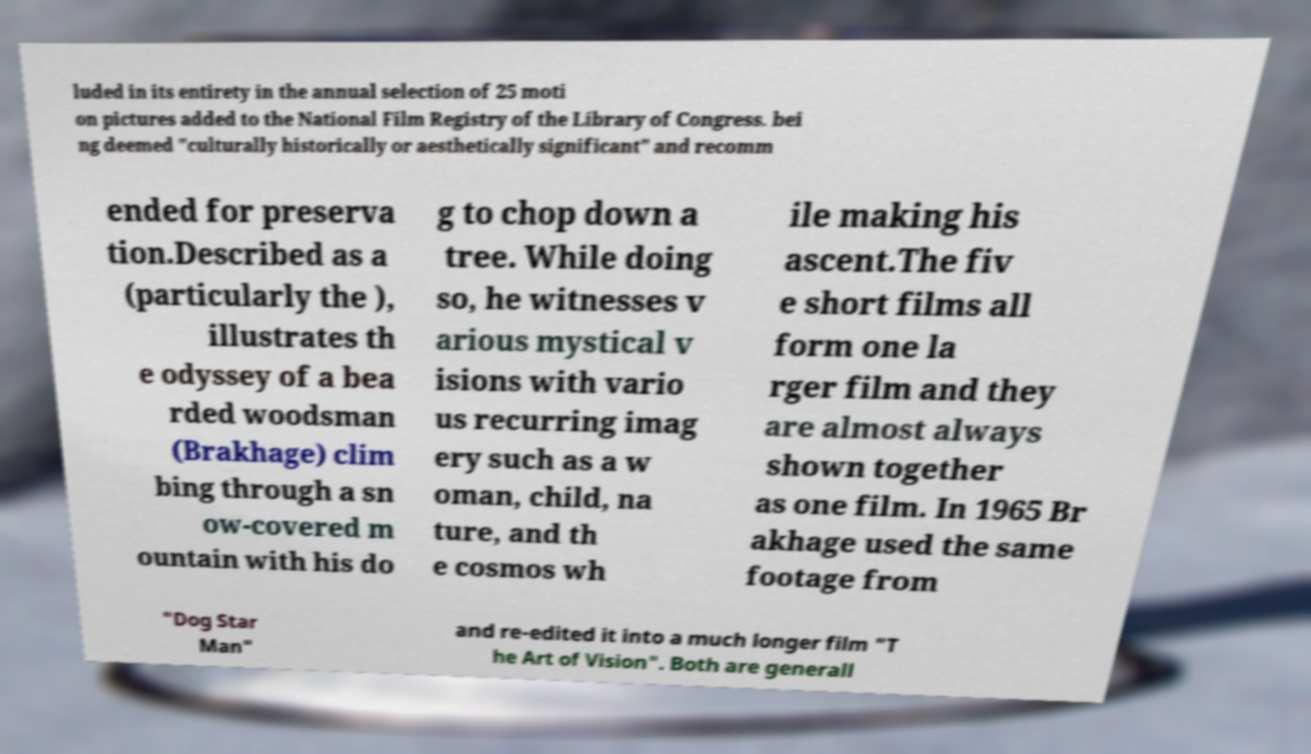There's text embedded in this image that I need extracted. Can you transcribe it verbatim? luded in its entirety in the annual selection of 25 moti on pictures added to the National Film Registry of the Library of Congress. bei ng deemed "culturally historically or aesthetically significant" and recomm ended for preserva tion.Described as a (particularly the ), illustrates th e odyssey of a bea rded woodsman (Brakhage) clim bing through a sn ow-covered m ountain with his do g to chop down a tree. While doing so, he witnesses v arious mystical v isions with vario us recurring imag ery such as a w oman, child, na ture, and th e cosmos wh ile making his ascent.The fiv e short films all form one la rger film and they are almost always shown together as one film. In 1965 Br akhage used the same footage from "Dog Star Man" and re-edited it into a much longer film "T he Art of Vision". Both are generall 